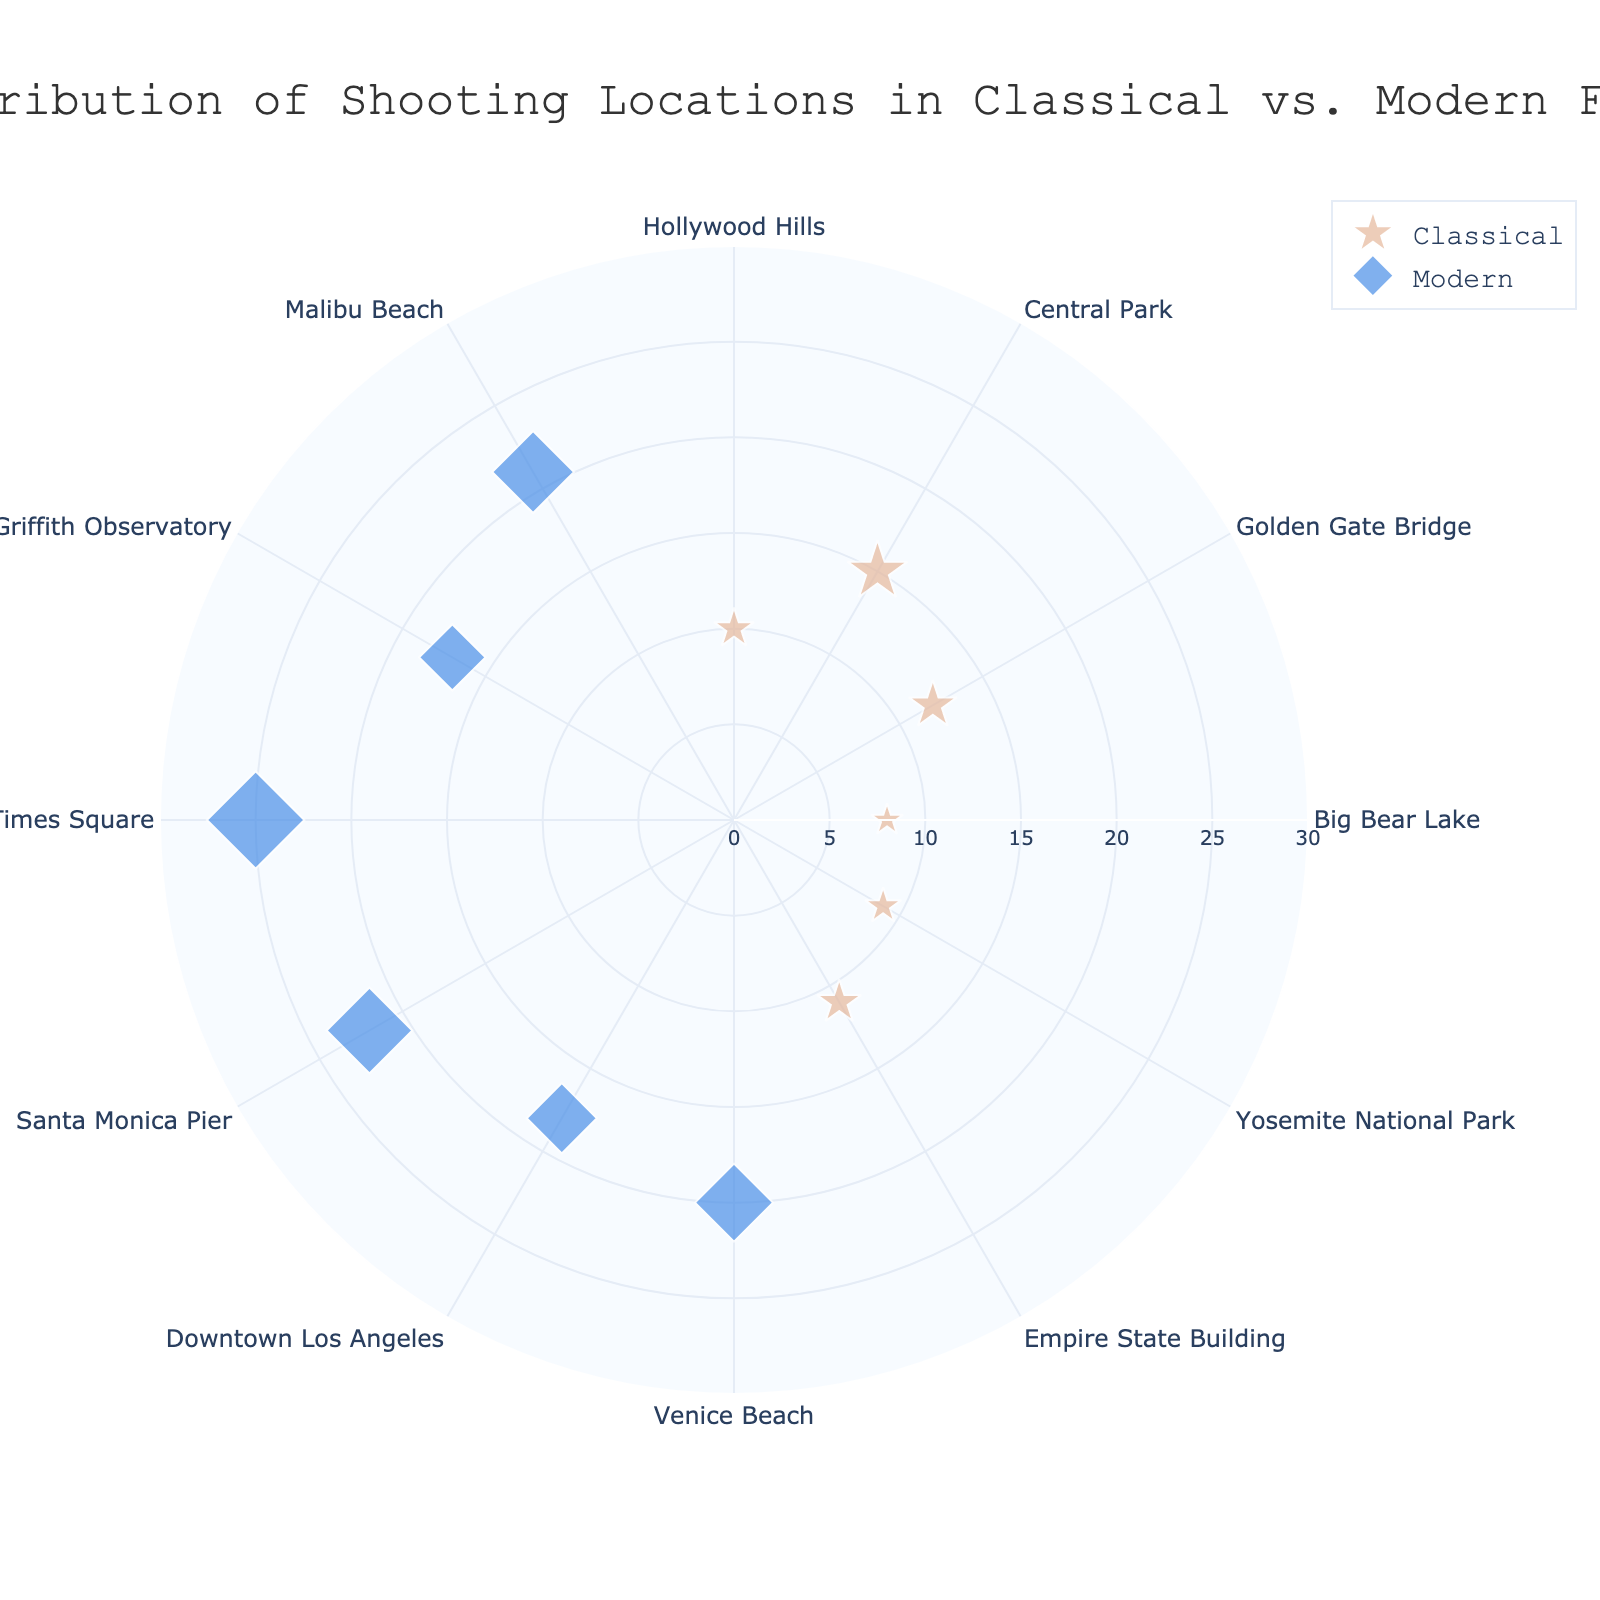What is the title of the figure? The title is located at the top of the figure. It is usually displayed in a larger font size and central alignment.
Answer: Distribution of Shooting Locations in Classical vs. Modern Films How many classical era locations have a frequency greater than 10? We look at the radial axis values corresponding to the markers of the classical era, which are colored differently from modern era markers. We then determine which of these locations have a frequency greater than 10. According to the data, three locations (Central Park, Golden Gate Bridge, and Empire State Building) fit this criteria.
Answer: 3 Which location has the highest frequency in modern films? We identify the markers for the modern era (colored differently and with a distinct symbol) and check the frequency values. The highest frequency marker for modern films is at Times Square with a frequency of 25.
Answer: Times Square What is the difference in frequency between the locations with the highest and lowest values in classical films? We first find the marker with the highest frequency (Central Park, 15) and the one with the lowest frequency (Big Bear Lake, 8) within the classical era set. The difference is calculated as 15 - 8.
Answer: 7 Which era has a more densely packed distribution of shooting locations? By visually examining the scatter points, we can see that the modern era markers are spread out with a higher number of closely packed locations when compared to the classical era markers. Thus, modern era locations seem more densely packed.
Answer: Modern Are there more classical or modern shooting locations in the dataset? We count the number of unique markers (distinct by color and symbol) for each era. There are 5 classical locations and 7 modern locations present in the dataset.
Answer: Modern How many locations in modern films have a frequency greater than or equal to 20? By examining the frequency values for the modern era markers and counting those that are 20 or higher, we find that three locations (Venice Beach, Santa Monica Pier, Malibu Beach, and Times Square) meet this criterion.
Answer: 4 What is the total frequency of all classical shooting locations? We sum up the frequency values for all classical era locations: Hollywood Hills (10) + Central Park (15) + Golden Gate Bridge (12) + Big Bear Lake (8) + Yosemite National Park (9) + Empire State Building (11). This sum is calculated as 10 + 15 + 12 + 8 + 9 + 11.
Answer: 65 How does the frequency of Downtown Los Angeles compare to that of Griffith Observatory in modern films? We compare the frequency values directly. Downtown Los Angeles has a frequency of 18, while Griffith Observatory has a frequency of 17. Therefore, Downtown Los Angeles has a slightly higher frequency.
Answer: Downtown Los Angeles has a higher frequency What is the average frequency of shooting locations in modern films? We sum up the frequency values for all modern era locations and divide by the number of modern locations: (20 + 18 + 22 + 25 + 17 + 21) / 6. The sum is 123 and dividing by 6 gives a mean of 20.5.
Answer: 20.5 